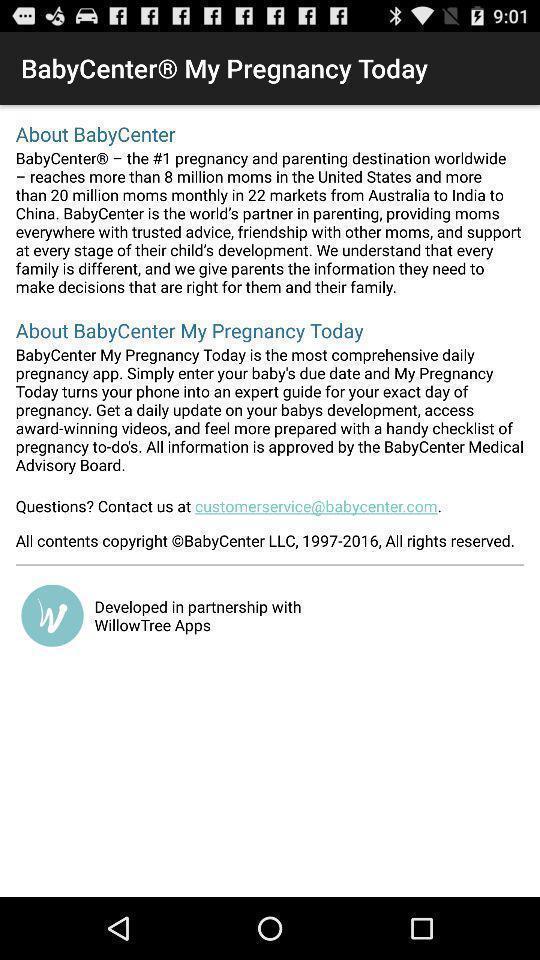Describe the content in this image. Screen displaying information about app. 